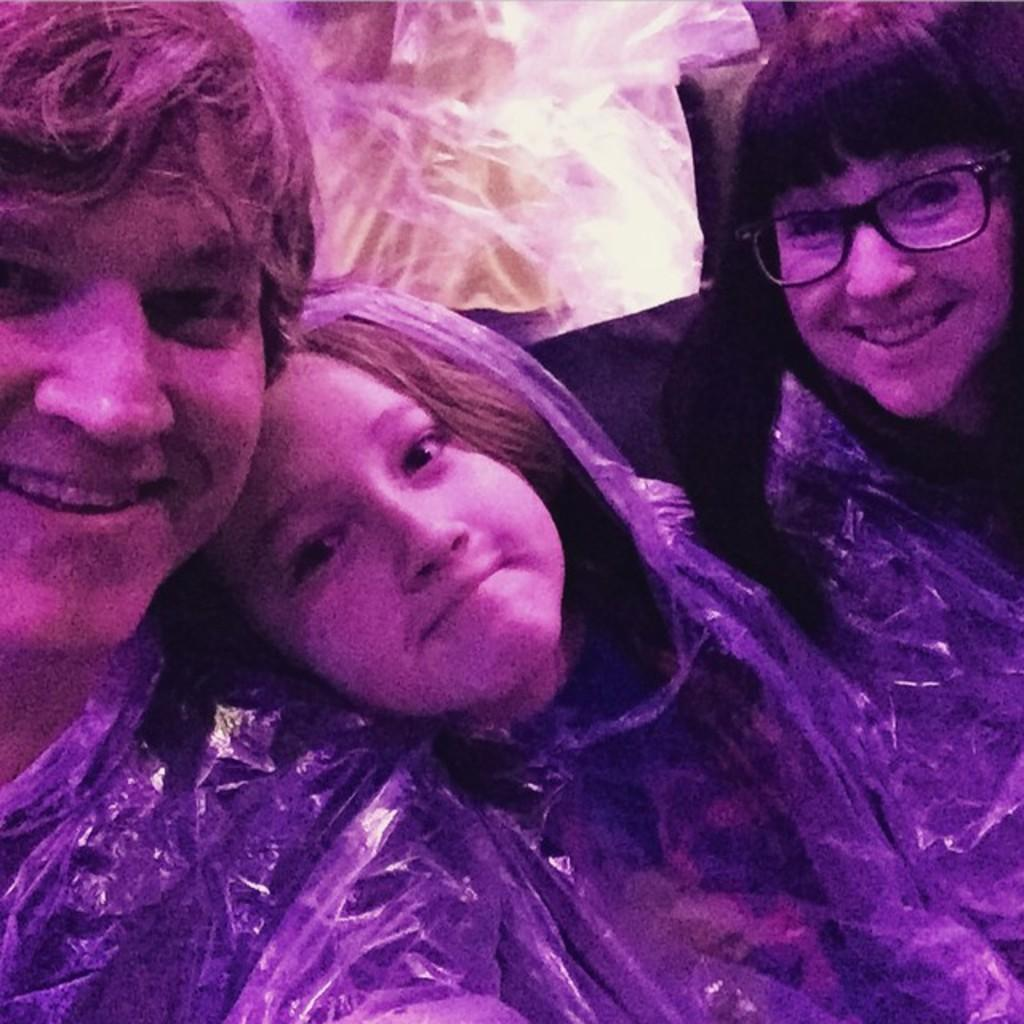What are the people in the image doing? The people sitting in the image are smiling. Are there any other people in the image besides those sitting? Yes, there are people standing in the image. Can you see any squirrels holding a twig and a chain in the image? There are no squirrels or any objects like a twig or chain present in the image. 